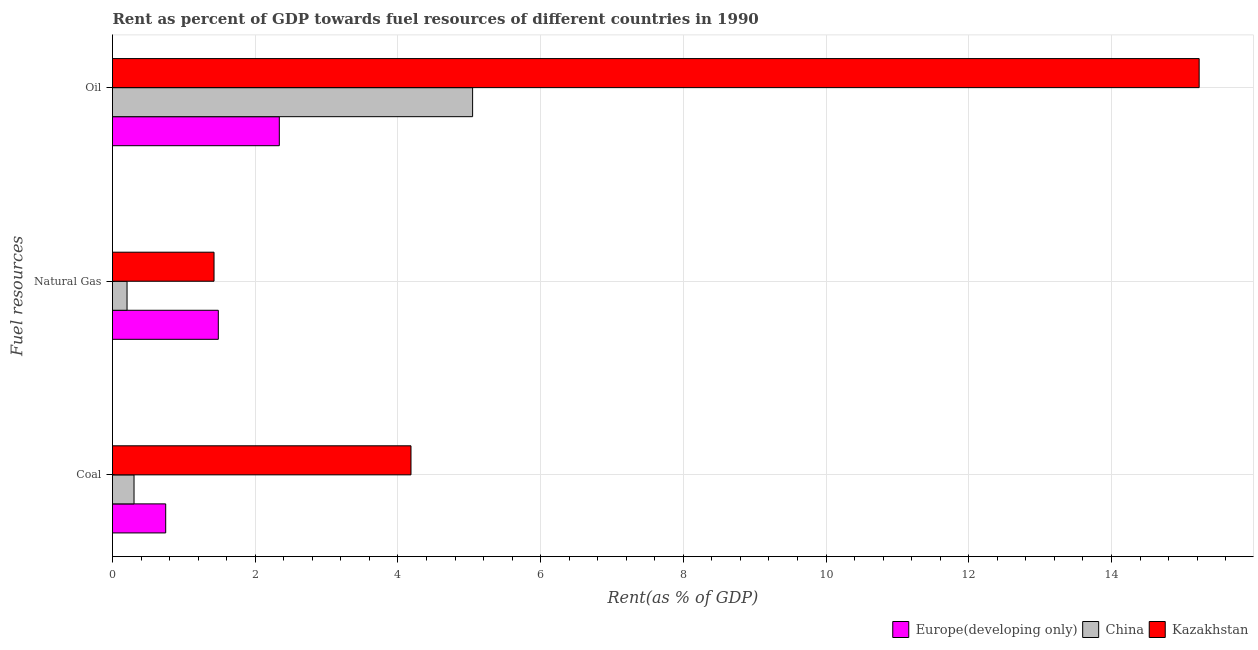How many different coloured bars are there?
Give a very brief answer. 3. How many groups of bars are there?
Provide a succinct answer. 3. Are the number of bars per tick equal to the number of legend labels?
Provide a short and direct response. Yes. Are the number of bars on each tick of the Y-axis equal?
Provide a succinct answer. Yes. How many bars are there on the 1st tick from the bottom?
Your answer should be compact. 3. What is the label of the 1st group of bars from the top?
Keep it short and to the point. Oil. What is the rent towards coal in Kazakhstan?
Give a very brief answer. 4.18. Across all countries, what is the maximum rent towards natural gas?
Provide a short and direct response. 1.48. Across all countries, what is the minimum rent towards coal?
Ensure brevity in your answer.  0.3. In which country was the rent towards natural gas maximum?
Your response must be concise. Europe(developing only). In which country was the rent towards natural gas minimum?
Ensure brevity in your answer.  China. What is the total rent towards coal in the graph?
Your response must be concise. 5.23. What is the difference between the rent towards oil in China and that in Kazakhstan?
Your response must be concise. -10.18. What is the difference between the rent towards coal in Kazakhstan and the rent towards oil in China?
Keep it short and to the point. -0.86. What is the average rent towards natural gas per country?
Your answer should be compact. 1.04. What is the difference between the rent towards natural gas and rent towards oil in Kazakhstan?
Your answer should be very brief. -13.81. In how many countries, is the rent towards oil greater than 1.2000000000000002 %?
Your answer should be compact. 3. What is the ratio of the rent towards coal in China to that in Kazakhstan?
Offer a terse response. 0.07. Is the difference between the rent towards coal in Kazakhstan and Europe(developing only) greater than the difference between the rent towards oil in Kazakhstan and Europe(developing only)?
Offer a terse response. No. What is the difference between the highest and the second highest rent towards oil?
Your answer should be compact. 10.18. What is the difference between the highest and the lowest rent towards oil?
Ensure brevity in your answer.  12.89. What does the 1st bar from the top in Coal represents?
Your answer should be very brief. Kazakhstan. What does the 3rd bar from the bottom in Oil represents?
Make the answer very short. Kazakhstan. Is it the case that in every country, the sum of the rent towards coal and rent towards natural gas is greater than the rent towards oil?
Offer a terse response. No. How many bars are there?
Give a very brief answer. 9. How many countries are there in the graph?
Your answer should be very brief. 3. Are the values on the major ticks of X-axis written in scientific E-notation?
Keep it short and to the point. No. Does the graph contain any zero values?
Your answer should be very brief. No. Where does the legend appear in the graph?
Offer a very short reply. Bottom right. How are the legend labels stacked?
Offer a very short reply. Horizontal. What is the title of the graph?
Offer a very short reply. Rent as percent of GDP towards fuel resources of different countries in 1990. What is the label or title of the X-axis?
Ensure brevity in your answer.  Rent(as % of GDP). What is the label or title of the Y-axis?
Your answer should be very brief. Fuel resources. What is the Rent(as % of GDP) in Europe(developing only) in Coal?
Provide a succinct answer. 0.75. What is the Rent(as % of GDP) of China in Coal?
Ensure brevity in your answer.  0.3. What is the Rent(as % of GDP) in Kazakhstan in Coal?
Provide a short and direct response. 4.18. What is the Rent(as % of GDP) of Europe(developing only) in Natural Gas?
Give a very brief answer. 1.48. What is the Rent(as % of GDP) in China in Natural Gas?
Offer a very short reply. 0.2. What is the Rent(as % of GDP) in Kazakhstan in Natural Gas?
Offer a very short reply. 1.42. What is the Rent(as % of GDP) of Europe(developing only) in Oil?
Your answer should be very brief. 2.34. What is the Rent(as % of GDP) of China in Oil?
Give a very brief answer. 5.05. What is the Rent(as % of GDP) in Kazakhstan in Oil?
Offer a terse response. 15.23. Across all Fuel resources, what is the maximum Rent(as % of GDP) of Europe(developing only)?
Your response must be concise. 2.34. Across all Fuel resources, what is the maximum Rent(as % of GDP) in China?
Offer a terse response. 5.05. Across all Fuel resources, what is the maximum Rent(as % of GDP) of Kazakhstan?
Offer a terse response. 15.23. Across all Fuel resources, what is the minimum Rent(as % of GDP) in Europe(developing only)?
Provide a succinct answer. 0.75. Across all Fuel resources, what is the minimum Rent(as % of GDP) of China?
Provide a succinct answer. 0.2. Across all Fuel resources, what is the minimum Rent(as % of GDP) in Kazakhstan?
Ensure brevity in your answer.  1.42. What is the total Rent(as % of GDP) in Europe(developing only) in the graph?
Offer a terse response. 4.57. What is the total Rent(as % of GDP) in China in the graph?
Offer a very short reply. 5.55. What is the total Rent(as % of GDP) of Kazakhstan in the graph?
Your response must be concise. 20.84. What is the difference between the Rent(as % of GDP) of Europe(developing only) in Coal and that in Natural Gas?
Make the answer very short. -0.74. What is the difference between the Rent(as % of GDP) of China in Coal and that in Natural Gas?
Offer a terse response. 0.1. What is the difference between the Rent(as % of GDP) in Kazakhstan in Coal and that in Natural Gas?
Give a very brief answer. 2.76. What is the difference between the Rent(as % of GDP) of Europe(developing only) in Coal and that in Oil?
Make the answer very short. -1.59. What is the difference between the Rent(as % of GDP) of China in Coal and that in Oil?
Give a very brief answer. -4.74. What is the difference between the Rent(as % of GDP) of Kazakhstan in Coal and that in Oil?
Your answer should be very brief. -11.05. What is the difference between the Rent(as % of GDP) in Europe(developing only) in Natural Gas and that in Oil?
Your answer should be compact. -0.85. What is the difference between the Rent(as % of GDP) in China in Natural Gas and that in Oil?
Give a very brief answer. -4.84. What is the difference between the Rent(as % of GDP) in Kazakhstan in Natural Gas and that in Oil?
Provide a short and direct response. -13.81. What is the difference between the Rent(as % of GDP) in Europe(developing only) in Coal and the Rent(as % of GDP) in China in Natural Gas?
Keep it short and to the point. 0.54. What is the difference between the Rent(as % of GDP) of Europe(developing only) in Coal and the Rent(as % of GDP) of Kazakhstan in Natural Gas?
Make the answer very short. -0.68. What is the difference between the Rent(as % of GDP) in China in Coal and the Rent(as % of GDP) in Kazakhstan in Natural Gas?
Provide a succinct answer. -1.12. What is the difference between the Rent(as % of GDP) in Europe(developing only) in Coal and the Rent(as % of GDP) in China in Oil?
Ensure brevity in your answer.  -4.3. What is the difference between the Rent(as % of GDP) of Europe(developing only) in Coal and the Rent(as % of GDP) of Kazakhstan in Oil?
Provide a short and direct response. -14.48. What is the difference between the Rent(as % of GDP) in China in Coal and the Rent(as % of GDP) in Kazakhstan in Oil?
Your response must be concise. -14.93. What is the difference between the Rent(as % of GDP) in Europe(developing only) in Natural Gas and the Rent(as % of GDP) in China in Oil?
Provide a succinct answer. -3.56. What is the difference between the Rent(as % of GDP) in Europe(developing only) in Natural Gas and the Rent(as % of GDP) in Kazakhstan in Oil?
Ensure brevity in your answer.  -13.75. What is the difference between the Rent(as % of GDP) in China in Natural Gas and the Rent(as % of GDP) in Kazakhstan in Oil?
Offer a very short reply. -15.03. What is the average Rent(as % of GDP) of Europe(developing only) per Fuel resources?
Offer a very short reply. 1.52. What is the average Rent(as % of GDP) of China per Fuel resources?
Provide a short and direct response. 1.85. What is the average Rent(as % of GDP) in Kazakhstan per Fuel resources?
Offer a very short reply. 6.95. What is the difference between the Rent(as % of GDP) in Europe(developing only) and Rent(as % of GDP) in China in Coal?
Keep it short and to the point. 0.44. What is the difference between the Rent(as % of GDP) of Europe(developing only) and Rent(as % of GDP) of Kazakhstan in Coal?
Your response must be concise. -3.44. What is the difference between the Rent(as % of GDP) of China and Rent(as % of GDP) of Kazakhstan in Coal?
Your answer should be compact. -3.88. What is the difference between the Rent(as % of GDP) of Europe(developing only) and Rent(as % of GDP) of China in Natural Gas?
Make the answer very short. 1.28. What is the difference between the Rent(as % of GDP) of Europe(developing only) and Rent(as % of GDP) of Kazakhstan in Natural Gas?
Your answer should be very brief. 0.06. What is the difference between the Rent(as % of GDP) of China and Rent(as % of GDP) of Kazakhstan in Natural Gas?
Offer a very short reply. -1.22. What is the difference between the Rent(as % of GDP) of Europe(developing only) and Rent(as % of GDP) of China in Oil?
Provide a short and direct response. -2.71. What is the difference between the Rent(as % of GDP) of Europe(developing only) and Rent(as % of GDP) of Kazakhstan in Oil?
Make the answer very short. -12.89. What is the difference between the Rent(as % of GDP) of China and Rent(as % of GDP) of Kazakhstan in Oil?
Provide a succinct answer. -10.18. What is the ratio of the Rent(as % of GDP) in Europe(developing only) in Coal to that in Natural Gas?
Provide a short and direct response. 0.5. What is the ratio of the Rent(as % of GDP) in China in Coal to that in Natural Gas?
Make the answer very short. 1.48. What is the ratio of the Rent(as % of GDP) of Kazakhstan in Coal to that in Natural Gas?
Make the answer very short. 2.94. What is the ratio of the Rent(as % of GDP) in Europe(developing only) in Coal to that in Oil?
Your response must be concise. 0.32. What is the ratio of the Rent(as % of GDP) in China in Coal to that in Oil?
Ensure brevity in your answer.  0.06. What is the ratio of the Rent(as % of GDP) in Kazakhstan in Coal to that in Oil?
Keep it short and to the point. 0.27. What is the ratio of the Rent(as % of GDP) in Europe(developing only) in Natural Gas to that in Oil?
Offer a very short reply. 0.63. What is the ratio of the Rent(as % of GDP) in China in Natural Gas to that in Oil?
Keep it short and to the point. 0.04. What is the ratio of the Rent(as % of GDP) of Kazakhstan in Natural Gas to that in Oil?
Keep it short and to the point. 0.09. What is the difference between the highest and the second highest Rent(as % of GDP) of Europe(developing only)?
Your answer should be very brief. 0.85. What is the difference between the highest and the second highest Rent(as % of GDP) in China?
Provide a short and direct response. 4.74. What is the difference between the highest and the second highest Rent(as % of GDP) of Kazakhstan?
Offer a terse response. 11.05. What is the difference between the highest and the lowest Rent(as % of GDP) of Europe(developing only)?
Provide a short and direct response. 1.59. What is the difference between the highest and the lowest Rent(as % of GDP) of China?
Provide a short and direct response. 4.84. What is the difference between the highest and the lowest Rent(as % of GDP) of Kazakhstan?
Offer a terse response. 13.81. 